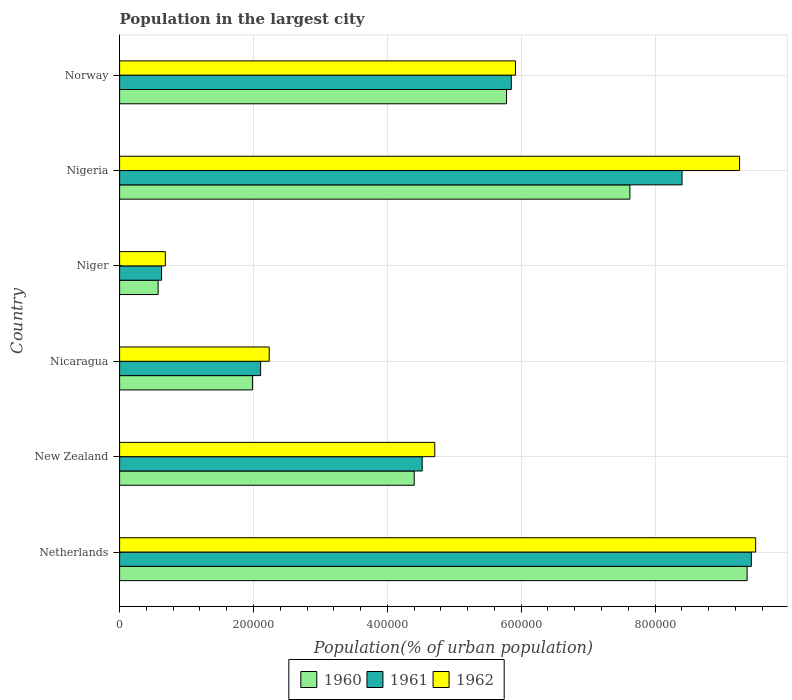How many different coloured bars are there?
Keep it short and to the point. 3. How many bars are there on the 3rd tick from the top?
Keep it short and to the point. 3. What is the population in the largest city in 1961 in New Zealand?
Keep it short and to the point. 4.52e+05. Across all countries, what is the maximum population in the largest city in 1961?
Keep it short and to the point. 9.44e+05. Across all countries, what is the minimum population in the largest city in 1960?
Offer a terse response. 5.75e+04. In which country was the population in the largest city in 1961 maximum?
Offer a very short reply. Netherlands. In which country was the population in the largest city in 1960 minimum?
Offer a very short reply. Niger. What is the total population in the largest city in 1960 in the graph?
Offer a terse response. 2.97e+06. What is the difference between the population in the largest city in 1962 in Netherlands and that in Niger?
Make the answer very short. 8.82e+05. What is the difference between the population in the largest city in 1961 in New Zealand and the population in the largest city in 1960 in Nigeria?
Provide a short and direct response. -3.10e+05. What is the average population in the largest city in 1961 per country?
Offer a terse response. 5.16e+05. What is the difference between the population in the largest city in 1960 and population in the largest city in 1961 in Niger?
Make the answer very short. -5156. In how many countries, is the population in the largest city in 1961 greater than 800000 %?
Offer a very short reply. 2. What is the ratio of the population in the largest city in 1960 in New Zealand to that in Niger?
Provide a succinct answer. 7.65. Is the difference between the population in the largest city in 1960 in Nicaragua and Nigeria greater than the difference between the population in the largest city in 1961 in Nicaragua and Nigeria?
Your answer should be very brief. Yes. What is the difference between the highest and the second highest population in the largest city in 1960?
Provide a succinct answer. 1.75e+05. What is the difference between the highest and the lowest population in the largest city in 1961?
Your response must be concise. 8.81e+05. In how many countries, is the population in the largest city in 1960 greater than the average population in the largest city in 1960 taken over all countries?
Your answer should be very brief. 3. Is the sum of the population in the largest city in 1961 in Nigeria and Norway greater than the maximum population in the largest city in 1960 across all countries?
Give a very brief answer. Yes. What does the 1st bar from the bottom in Norway represents?
Your answer should be very brief. 1960. Is it the case that in every country, the sum of the population in the largest city in 1960 and population in the largest city in 1962 is greater than the population in the largest city in 1961?
Your answer should be very brief. Yes. Are all the bars in the graph horizontal?
Offer a terse response. Yes. Does the graph contain grids?
Offer a very short reply. Yes. Where does the legend appear in the graph?
Offer a terse response. Bottom center. What is the title of the graph?
Your response must be concise. Population in the largest city. Does "1966" appear as one of the legend labels in the graph?
Ensure brevity in your answer.  No. What is the label or title of the X-axis?
Offer a terse response. Population(% of urban population). What is the label or title of the Y-axis?
Provide a short and direct response. Country. What is the Population(% of urban population) in 1960 in Netherlands?
Provide a succinct answer. 9.37e+05. What is the Population(% of urban population) in 1961 in Netherlands?
Your response must be concise. 9.44e+05. What is the Population(% of urban population) of 1962 in Netherlands?
Provide a succinct answer. 9.50e+05. What is the Population(% of urban population) of 1960 in New Zealand?
Your answer should be very brief. 4.40e+05. What is the Population(% of urban population) of 1961 in New Zealand?
Offer a terse response. 4.52e+05. What is the Population(% of urban population) of 1962 in New Zealand?
Provide a succinct answer. 4.71e+05. What is the Population(% of urban population) in 1960 in Nicaragua?
Provide a succinct answer. 1.99e+05. What is the Population(% of urban population) of 1961 in Nicaragua?
Your response must be concise. 2.11e+05. What is the Population(% of urban population) of 1962 in Nicaragua?
Provide a short and direct response. 2.24e+05. What is the Population(% of urban population) of 1960 in Niger?
Offer a very short reply. 5.75e+04. What is the Population(% of urban population) of 1961 in Niger?
Provide a short and direct response. 6.27e+04. What is the Population(% of urban population) of 1962 in Niger?
Your answer should be very brief. 6.83e+04. What is the Population(% of urban population) of 1960 in Nigeria?
Give a very brief answer. 7.62e+05. What is the Population(% of urban population) of 1961 in Nigeria?
Your response must be concise. 8.40e+05. What is the Population(% of urban population) of 1962 in Nigeria?
Your response must be concise. 9.26e+05. What is the Population(% of urban population) in 1960 in Norway?
Ensure brevity in your answer.  5.78e+05. What is the Population(% of urban population) of 1961 in Norway?
Offer a terse response. 5.85e+05. What is the Population(% of urban population) of 1962 in Norway?
Your response must be concise. 5.91e+05. Across all countries, what is the maximum Population(% of urban population) in 1960?
Offer a terse response. 9.37e+05. Across all countries, what is the maximum Population(% of urban population) in 1961?
Give a very brief answer. 9.44e+05. Across all countries, what is the maximum Population(% of urban population) in 1962?
Keep it short and to the point. 9.50e+05. Across all countries, what is the minimum Population(% of urban population) in 1960?
Offer a terse response. 5.75e+04. Across all countries, what is the minimum Population(% of urban population) in 1961?
Offer a terse response. 6.27e+04. Across all countries, what is the minimum Population(% of urban population) of 1962?
Your answer should be compact. 6.83e+04. What is the total Population(% of urban population) of 1960 in the graph?
Provide a succinct answer. 2.97e+06. What is the total Population(% of urban population) in 1961 in the graph?
Offer a very short reply. 3.09e+06. What is the total Population(% of urban population) in 1962 in the graph?
Provide a succinct answer. 3.23e+06. What is the difference between the Population(% of urban population) of 1960 in Netherlands and that in New Zealand?
Your answer should be compact. 4.97e+05. What is the difference between the Population(% of urban population) in 1961 in Netherlands and that in New Zealand?
Offer a very short reply. 4.92e+05. What is the difference between the Population(% of urban population) of 1962 in Netherlands and that in New Zealand?
Provide a succinct answer. 4.79e+05. What is the difference between the Population(% of urban population) of 1960 in Netherlands and that in Nicaragua?
Provide a succinct answer. 7.39e+05. What is the difference between the Population(% of urban population) in 1961 in Netherlands and that in Nicaragua?
Your answer should be compact. 7.33e+05. What is the difference between the Population(% of urban population) of 1962 in Netherlands and that in Nicaragua?
Give a very brief answer. 7.27e+05. What is the difference between the Population(% of urban population) of 1960 in Netherlands and that in Niger?
Provide a succinct answer. 8.80e+05. What is the difference between the Population(% of urban population) in 1961 in Netherlands and that in Niger?
Your response must be concise. 8.81e+05. What is the difference between the Population(% of urban population) in 1962 in Netherlands and that in Niger?
Your answer should be compact. 8.82e+05. What is the difference between the Population(% of urban population) of 1960 in Netherlands and that in Nigeria?
Offer a terse response. 1.75e+05. What is the difference between the Population(% of urban population) of 1961 in Netherlands and that in Nigeria?
Your answer should be very brief. 1.04e+05. What is the difference between the Population(% of urban population) in 1962 in Netherlands and that in Nigeria?
Your answer should be very brief. 2.41e+04. What is the difference between the Population(% of urban population) in 1960 in Netherlands and that in Norway?
Your response must be concise. 3.59e+05. What is the difference between the Population(% of urban population) of 1961 in Netherlands and that in Norway?
Provide a succinct answer. 3.59e+05. What is the difference between the Population(% of urban population) of 1962 in Netherlands and that in Norway?
Offer a terse response. 3.59e+05. What is the difference between the Population(% of urban population) in 1960 in New Zealand and that in Nicaragua?
Offer a very short reply. 2.42e+05. What is the difference between the Population(% of urban population) in 1961 in New Zealand and that in Nicaragua?
Keep it short and to the point. 2.41e+05. What is the difference between the Population(% of urban population) in 1962 in New Zealand and that in Nicaragua?
Make the answer very short. 2.47e+05. What is the difference between the Population(% of urban population) in 1960 in New Zealand and that in Niger?
Ensure brevity in your answer.  3.83e+05. What is the difference between the Population(% of urban population) in 1961 in New Zealand and that in Niger?
Offer a terse response. 3.89e+05. What is the difference between the Population(% of urban population) in 1962 in New Zealand and that in Niger?
Your response must be concise. 4.03e+05. What is the difference between the Population(% of urban population) of 1960 in New Zealand and that in Nigeria?
Provide a succinct answer. -3.22e+05. What is the difference between the Population(% of urban population) of 1961 in New Zealand and that in Nigeria?
Provide a short and direct response. -3.88e+05. What is the difference between the Population(% of urban population) of 1962 in New Zealand and that in Nigeria?
Your answer should be compact. -4.55e+05. What is the difference between the Population(% of urban population) in 1960 in New Zealand and that in Norway?
Provide a short and direct response. -1.38e+05. What is the difference between the Population(% of urban population) of 1961 in New Zealand and that in Norway?
Give a very brief answer. -1.33e+05. What is the difference between the Population(% of urban population) of 1962 in New Zealand and that in Norway?
Keep it short and to the point. -1.21e+05. What is the difference between the Population(% of urban population) in 1960 in Nicaragua and that in Niger?
Keep it short and to the point. 1.41e+05. What is the difference between the Population(% of urban population) of 1961 in Nicaragua and that in Niger?
Keep it short and to the point. 1.48e+05. What is the difference between the Population(% of urban population) in 1962 in Nicaragua and that in Niger?
Give a very brief answer. 1.55e+05. What is the difference between the Population(% of urban population) of 1960 in Nicaragua and that in Nigeria?
Keep it short and to the point. -5.64e+05. What is the difference between the Population(% of urban population) of 1961 in Nicaragua and that in Nigeria?
Your response must be concise. -6.30e+05. What is the difference between the Population(% of urban population) of 1962 in Nicaragua and that in Nigeria?
Your answer should be compact. -7.03e+05. What is the difference between the Population(% of urban population) of 1960 in Nicaragua and that in Norway?
Provide a short and direct response. -3.79e+05. What is the difference between the Population(% of urban population) of 1961 in Nicaragua and that in Norway?
Offer a very short reply. -3.75e+05. What is the difference between the Population(% of urban population) of 1962 in Nicaragua and that in Norway?
Provide a succinct answer. -3.68e+05. What is the difference between the Population(% of urban population) in 1960 in Niger and that in Nigeria?
Your response must be concise. -7.05e+05. What is the difference between the Population(% of urban population) in 1961 in Niger and that in Nigeria?
Offer a terse response. -7.78e+05. What is the difference between the Population(% of urban population) in 1962 in Niger and that in Nigeria?
Offer a very short reply. -8.58e+05. What is the difference between the Population(% of urban population) in 1960 in Niger and that in Norway?
Your response must be concise. -5.20e+05. What is the difference between the Population(% of urban population) in 1961 in Niger and that in Norway?
Your response must be concise. -5.23e+05. What is the difference between the Population(% of urban population) in 1962 in Niger and that in Norway?
Give a very brief answer. -5.23e+05. What is the difference between the Population(% of urban population) of 1960 in Nigeria and that in Norway?
Offer a very short reply. 1.84e+05. What is the difference between the Population(% of urban population) of 1961 in Nigeria and that in Norway?
Offer a terse response. 2.55e+05. What is the difference between the Population(% of urban population) of 1962 in Nigeria and that in Norway?
Offer a terse response. 3.35e+05. What is the difference between the Population(% of urban population) of 1960 in Netherlands and the Population(% of urban population) of 1961 in New Zealand?
Your answer should be very brief. 4.85e+05. What is the difference between the Population(% of urban population) of 1960 in Netherlands and the Population(% of urban population) of 1962 in New Zealand?
Provide a succinct answer. 4.67e+05. What is the difference between the Population(% of urban population) in 1961 in Netherlands and the Population(% of urban population) in 1962 in New Zealand?
Keep it short and to the point. 4.73e+05. What is the difference between the Population(% of urban population) in 1960 in Netherlands and the Population(% of urban population) in 1961 in Nicaragua?
Offer a very short reply. 7.27e+05. What is the difference between the Population(% of urban population) in 1960 in Netherlands and the Population(% of urban population) in 1962 in Nicaragua?
Give a very brief answer. 7.14e+05. What is the difference between the Population(% of urban population) in 1961 in Netherlands and the Population(% of urban population) in 1962 in Nicaragua?
Provide a short and direct response. 7.20e+05. What is the difference between the Population(% of urban population) in 1960 in Netherlands and the Population(% of urban population) in 1961 in Niger?
Make the answer very short. 8.75e+05. What is the difference between the Population(% of urban population) in 1960 in Netherlands and the Population(% of urban population) in 1962 in Niger?
Offer a very short reply. 8.69e+05. What is the difference between the Population(% of urban population) in 1961 in Netherlands and the Population(% of urban population) in 1962 in Niger?
Offer a very short reply. 8.76e+05. What is the difference between the Population(% of urban population) of 1960 in Netherlands and the Population(% of urban population) of 1961 in Nigeria?
Offer a very short reply. 9.72e+04. What is the difference between the Population(% of urban population) in 1960 in Netherlands and the Population(% of urban population) in 1962 in Nigeria?
Provide a succinct answer. 1.12e+04. What is the difference between the Population(% of urban population) in 1961 in Netherlands and the Population(% of urban population) in 1962 in Nigeria?
Your response must be concise. 1.76e+04. What is the difference between the Population(% of urban population) in 1960 in Netherlands and the Population(% of urban population) in 1961 in Norway?
Make the answer very short. 3.52e+05. What is the difference between the Population(% of urban population) in 1960 in Netherlands and the Population(% of urban population) in 1962 in Norway?
Keep it short and to the point. 3.46e+05. What is the difference between the Population(% of urban population) of 1961 in Netherlands and the Population(% of urban population) of 1962 in Norway?
Offer a very short reply. 3.52e+05. What is the difference between the Population(% of urban population) of 1960 in New Zealand and the Population(% of urban population) of 1961 in Nicaragua?
Make the answer very short. 2.29e+05. What is the difference between the Population(% of urban population) in 1960 in New Zealand and the Population(% of urban population) in 1962 in Nicaragua?
Keep it short and to the point. 2.17e+05. What is the difference between the Population(% of urban population) in 1961 in New Zealand and the Population(% of urban population) in 1962 in Nicaragua?
Provide a short and direct response. 2.29e+05. What is the difference between the Population(% of urban population) of 1960 in New Zealand and the Population(% of urban population) of 1961 in Niger?
Offer a terse response. 3.77e+05. What is the difference between the Population(% of urban population) in 1960 in New Zealand and the Population(% of urban population) in 1962 in Niger?
Offer a very short reply. 3.72e+05. What is the difference between the Population(% of urban population) of 1961 in New Zealand and the Population(% of urban population) of 1962 in Niger?
Provide a succinct answer. 3.84e+05. What is the difference between the Population(% of urban population) of 1960 in New Zealand and the Population(% of urban population) of 1961 in Nigeria?
Offer a terse response. -4.00e+05. What is the difference between the Population(% of urban population) of 1960 in New Zealand and the Population(% of urban population) of 1962 in Nigeria?
Your response must be concise. -4.86e+05. What is the difference between the Population(% of urban population) of 1961 in New Zealand and the Population(% of urban population) of 1962 in Nigeria?
Give a very brief answer. -4.74e+05. What is the difference between the Population(% of urban population) in 1960 in New Zealand and the Population(% of urban population) in 1961 in Norway?
Offer a terse response. -1.45e+05. What is the difference between the Population(% of urban population) of 1960 in New Zealand and the Population(% of urban population) of 1962 in Norway?
Offer a very short reply. -1.51e+05. What is the difference between the Population(% of urban population) in 1961 in New Zealand and the Population(% of urban population) in 1962 in Norway?
Ensure brevity in your answer.  -1.39e+05. What is the difference between the Population(% of urban population) in 1960 in Nicaragua and the Population(% of urban population) in 1961 in Niger?
Your answer should be compact. 1.36e+05. What is the difference between the Population(% of urban population) of 1960 in Nicaragua and the Population(% of urban population) of 1962 in Niger?
Your answer should be compact. 1.30e+05. What is the difference between the Population(% of urban population) in 1961 in Nicaragua and the Population(% of urban population) in 1962 in Niger?
Ensure brevity in your answer.  1.42e+05. What is the difference between the Population(% of urban population) of 1960 in Nicaragua and the Population(% of urban population) of 1961 in Nigeria?
Give a very brief answer. -6.42e+05. What is the difference between the Population(% of urban population) of 1960 in Nicaragua and the Population(% of urban population) of 1962 in Nigeria?
Make the answer very short. -7.28e+05. What is the difference between the Population(% of urban population) of 1961 in Nicaragua and the Population(% of urban population) of 1962 in Nigeria?
Offer a very short reply. -7.16e+05. What is the difference between the Population(% of urban population) of 1960 in Nicaragua and the Population(% of urban population) of 1961 in Norway?
Provide a short and direct response. -3.87e+05. What is the difference between the Population(% of urban population) in 1960 in Nicaragua and the Population(% of urban population) in 1962 in Norway?
Offer a very short reply. -3.93e+05. What is the difference between the Population(% of urban population) in 1961 in Nicaragua and the Population(% of urban population) in 1962 in Norway?
Your answer should be compact. -3.81e+05. What is the difference between the Population(% of urban population) in 1960 in Niger and the Population(% of urban population) in 1961 in Nigeria?
Provide a succinct answer. -7.83e+05. What is the difference between the Population(% of urban population) in 1960 in Niger and the Population(% of urban population) in 1962 in Nigeria?
Make the answer very short. -8.69e+05. What is the difference between the Population(% of urban population) of 1961 in Niger and the Population(% of urban population) of 1962 in Nigeria?
Offer a very short reply. -8.64e+05. What is the difference between the Population(% of urban population) in 1960 in Niger and the Population(% of urban population) in 1961 in Norway?
Keep it short and to the point. -5.28e+05. What is the difference between the Population(% of urban population) of 1960 in Niger and the Population(% of urban population) of 1962 in Norway?
Provide a short and direct response. -5.34e+05. What is the difference between the Population(% of urban population) in 1961 in Niger and the Population(% of urban population) in 1962 in Norway?
Your answer should be very brief. -5.29e+05. What is the difference between the Population(% of urban population) in 1960 in Nigeria and the Population(% of urban population) in 1961 in Norway?
Your answer should be compact. 1.77e+05. What is the difference between the Population(% of urban population) of 1960 in Nigeria and the Population(% of urban population) of 1962 in Norway?
Your response must be concise. 1.71e+05. What is the difference between the Population(% of urban population) in 1961 in Nigeria and the Population(% of urban population) in 1962 in Norway?
Keep it short and to the point. 2.49e+05. What is the average Population(% of urban population) in 1960 per country?
Your answer should be compact. 4.96e+05. What is the average Population(% of urban population) of 1961 per country?
Your answer should be compact. 5.16e+05. What is the average Population(% of urban population) in 1962 per country?
Your answer should be very brief. 5.38e+05. What is the difference between the Population(% of urban population) in 1960 and Population(% of urban population) in 1961 in Netherlands?
Offer a terse response. -6394. What is the difference between the Population(% of urban population) in 1960 and Population(% of urban population) in 1962 in Netherlands?
Provide a short and direct response. -1.28e+04. What is the difference between the Population(% of urban population) in 1961 and Population(% of urban population) in 1962 in Netherlands?
Your answer should be compact. -6446. What is the difference between the Population(% of urban population) of 1960 and Population(% of urban population) of 1961 in New Zealand?
Make the answer very short. -1.19e+04. What is the difference between the Population(% of urban population) of 1960 and Population(% of urban population) of 1962 in New Zealand?
Your response must be concise. -3.07e+04. What is the difference between the Population(% of urban population) of 1961 and Population(% of urban population) of 1962 in New Zealand?
Give a very brief answer. -1.88e+04. What is the difference between the Population(% of urban population) of 1960 and Population(% of urban population) of 1961 in Nicaragua?
Ensure brevity in your answer.  -1.21e+04. What is the difference between the Population(% of urban population) in 1960 and Population(% of urban population) in 1962 in Nicaragua?
Keep it short and to the point. -2.49e+04. What is the difference between the Population(% of urban population) of 1961 and Population(% of urban population) of 1962 in Nicaragua?
Offer a terse response. -1.28e+04. What is the difference between the Population(% of urban population) of 1960 and Population(% of urban population) of 1961 in Niger?
Provide a succinct answer. -5156. What is the difference between the Population(% of urban population) in 1960 and Population(% of urban population) in 1962 in Niger?
Make the answer very short. -1.08e+04. What is the difference between the Population(% of urban population) of 1961 and Population(% of urban population) of 1962 in Niger?
Make the answer very short. -5625. What is the difference between the Population(% of urban population) in 1960 and Population(% of urban population) in 1961 in Nigeria?
Provide a short and direct response. -7.79e+04. What is the difference between the Population(% of urban population) of 1960 and Population(% of urban population) of 1962 in Nigeria?
Offer a very short reply. -1.64e+05. What is the difference between the Population(% of urban population) in 1961 and Population(% of urban population) in 1962 in Nigeria?
Your answer should be very brief. -8.59e+04. What is the difference between the Population(% of urban population) in 1960 and Population(% of urban population) in 1961 in Norway?
Make the answer very short. -7186. What is the difference between the Population(% of urban population) of 1960 and Population(% of urban population) of 1962 in Norway?
Keep it short and to the point. -1.34e+04. What is the difference between the Population(% of urban population) of 1961 and Population(% of urban population) of 1962 in Norway?
Make the answer very short. -6168. What is the ratio of the Population(% of urban population) in 1960 in Netherlands to that in New Zealand?
Ensure brevity in your answer.  2.13. What is the ratio of the Population(% of urban population) of 1961 in Netherlands to that in New Zealand?
Offer a terse response. 2.09. What is the ratio of the Population(% of urban population) in 1962 in Netherlands to that in New Zealand?
Your response must be concise. 2.02. What is the ratio of the Population(% of urban population) in 1960 in Netherlands to that in Nicaragua?
Keep it short and to the point. 4.72. What is the ratio of the Population(% of urban population) of 1961 in Netherlands to that in Nicaragua?
Your answer should be compact. 4.48. What is the ratio of the Population(% of urban population) of 1962 in Netherlands to that in Nicaragua?
Offer a terse response. 4.25. What is the ratio of the Population(% of urban population) in 1960 in Netherlands to that in Niger?
Keep it short and to the point. 16.29. What is the ratio of the Population(% of urban population) in 1961 in Netherlands to that in Niger?
Your answer should be compact. 15.05. What is the ratio of the Population(% of urban population) in 1962 in Netherlands to that in Niger?
Your answer should be very brief. 13.91. What is the ratio of the Population(% of urban population) in 1960 in Netherlands to that in Nigeria?
Your answer should be compact. 1.23. What is the ratio of the Population(% of urban population) of 1961 in Netherlands to that in Nigeria?
Your answer should be very brief. 1.12. What is the ratio of the Population(% of urban population) of 1960 in Netherlands to that in Norway?
Make the answer very short. 1.62. What is the ratio of the Population(% of urban population) of 1961 in Netherlands to that in Norway?
Your response must be concise. 1.61. What is the ratio of the Population(% of urban population) in 1962 in Netherlands to that in Norway?
Provide a short and direct response. 1.61. What is the ratio of the Population(% of urban population) in 1960 in New Zealand to that in Nicaragua?
Your answer should be very brief. 2.22. What is the ratio of the Population(% of urban population) of 1961 in New Zealand to that in Nicaragua?
Give a very brief answer. 2.15. What is the ratio of the Population(% of urban population) in 1962 in New Zealand to that in Nicaragua?
Your answer should be very brief. 2.11. What is the ratio of the Population(% of urban population) of 1960 in New Zealand to that in Niger?
Offer a very short reply. 7.65. What is the ratio of the Population(% of urban population) in 1961 in New Zealand to that in Niger?
Keep it short and to the point. 7.21. What is the ratio of the Population(% of urban population) in 1962 in New Zealand to that in Niger?
Make the answer very short. 6.89. What is the ratio of the Population(% of urban population) in 1960 in New Zealand to that in Nigeria?
Your response must be concise. 0.58. What is the ratio of the Population(% of urban population) in 1961 in New Zealand to that in Nigeria?
Give a very brief answer. 0.54. What is the ratio of the Population(% of urban population) in 1962 in New Zealand to that in Nigeria?
Give a very brief answer. 0.51. What is the ratio of the Population(% of urban population) of 1960 in New Zealand to that in Norway?
Make the answer very short. 0.76. What is the ratio of the Population(% of urban population) in 1961 in New Zealand to that in Norway?
Offer a very short reply. 0.77. What is the ratio of the Population(% of urban population) in 1962 in New Zealand to that in Norway?
Offer a very short reply. 0.8. What is the ratio of the Population(% of urban population) in 1960 in Nicaragua to that in Niger?
Make the answer very short. 3.45. What is the ratio of the Population(% of urban population) in 1961 in Nicaragua to that in Niger?
Keep it short and to the point. 3.36. What is the ratio of the Population(% of urban population) in 1962 in Nicaragua to that in Niger?
Give a very brief answer. 3.27. What is the ratio of the Population(% of urban population) of 1960 in Nicaragua to that in Nigeria?
Give a very brief answer. 0.26. What is the ratio of the Population(% of urban population) of 1961 in Nicaragua to that in Nigeria?
Offer a very short reply. 0.25. What is the ratio of the Population(% of urban population) of 1962 in Nicaragua to that in Nigeria?
Offer a terse response. 0.24. What is the ratio of the Population(% of urban population) in 1960 in Nicaragua to that in Norway?
Your answer should be compact. 0.34. What is the ratio of the Population(% of urban population) of 1961 in Nicaragua to that in Norway?
Offer a very short reply. 0.36. What is the ratio of the Population(% of urban population) of 1962 in Nicaragua to that in Norway?
Your answer should be very brief. 0.38. What is the ratio of the Population(% of urban population) in 1960 in Niger to that in Nigeria?
Your answer should be very brief. 0.08. What is the ratio of the Population(% of urban population) of 1961 in Niger to that in Nigeria?
Make the answer very short. 0.07. What is the ratio of the Population(% of urban population) in 1962 in Niger to that in Nigeria?
Make the answer very short. 0.07. What is the ratio of the Population(% of urban population) of 1960 in Niger to that in Norway?
Your answer should be very brief. 0.1. What is the ratio of the Population(% of urban population) in 1961 in Niger to that in Norway?
Keep it short and to the point. 0.11. What is the ratio of the Population(% of urban population) in 1962 in Niger to that in Norway?
Give a very brief answer. 0.12. What is the ratio of the Population(% of urban population) of 1960 in Nigeria to that in Norway?
Keep it short and to the point. 1.32. What is the ratio of the Population(% of urban population) of 1961 in Nigeria to that in Norway?
Your response must be concise. 1.44. What is the ratio of the Population(% of urban population) of 1962 in Nigeria to that in Norway?
Provide a short and direct response. 1.57. What is the difference between the highest and the second highest Population(% of urban population) of 1960?
Offer a very short reply. 1.75e+05. What is the difference between the highest and the second highest Population(% of urban population) in 1961?
Offer a terse response. 1.04e+05. What is the difference between the highest and the second highest Population(% of urban population) in 1962?
Give a very brief answer. 2.41e+04. What is the difference between the highest and the lowest Population(% of urban population) in 1960?
Give a very brief answer. 8.80e+05. What is the difference between the highest and the lowest Population(% of urban population) of 1961?
Provide a succinct answer. 8.81e+05. What is the difference between the highest and the lowest Population(% of urban population) in 1962?
Make the answer very short. 8.82e+05. 